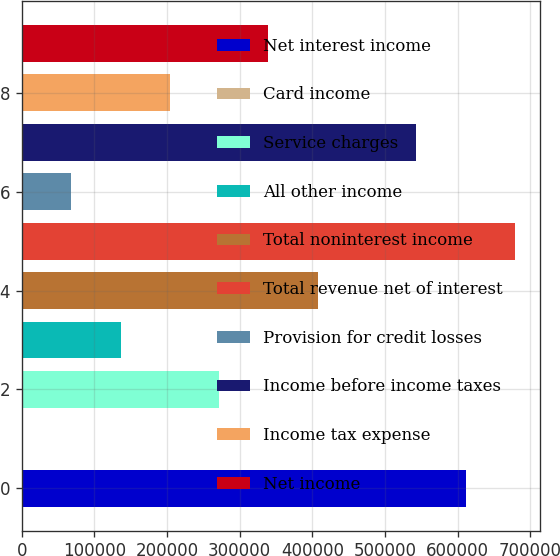Convert chart to OTSL. <chart><loc_0><loc_0><loc_500><loc_500><bar_chart><fcel>Net interest income<fcel>Card income<fcel>Service charges<fcel>All other income<fcel>Total noninterest income<fcel>Total revenue net of interest<fcel>Provision for credit losses<fcel>Income before income taxes<fcel>Income tax expense<fcel>Net income<nl><fcel>611376<fcel>8<fcel>271727<fcel>135868<fcel>407587<fcel>679306<fcel>67937.8<fcel>543446<fcel>203797<fcel>339657<nl></chart> 